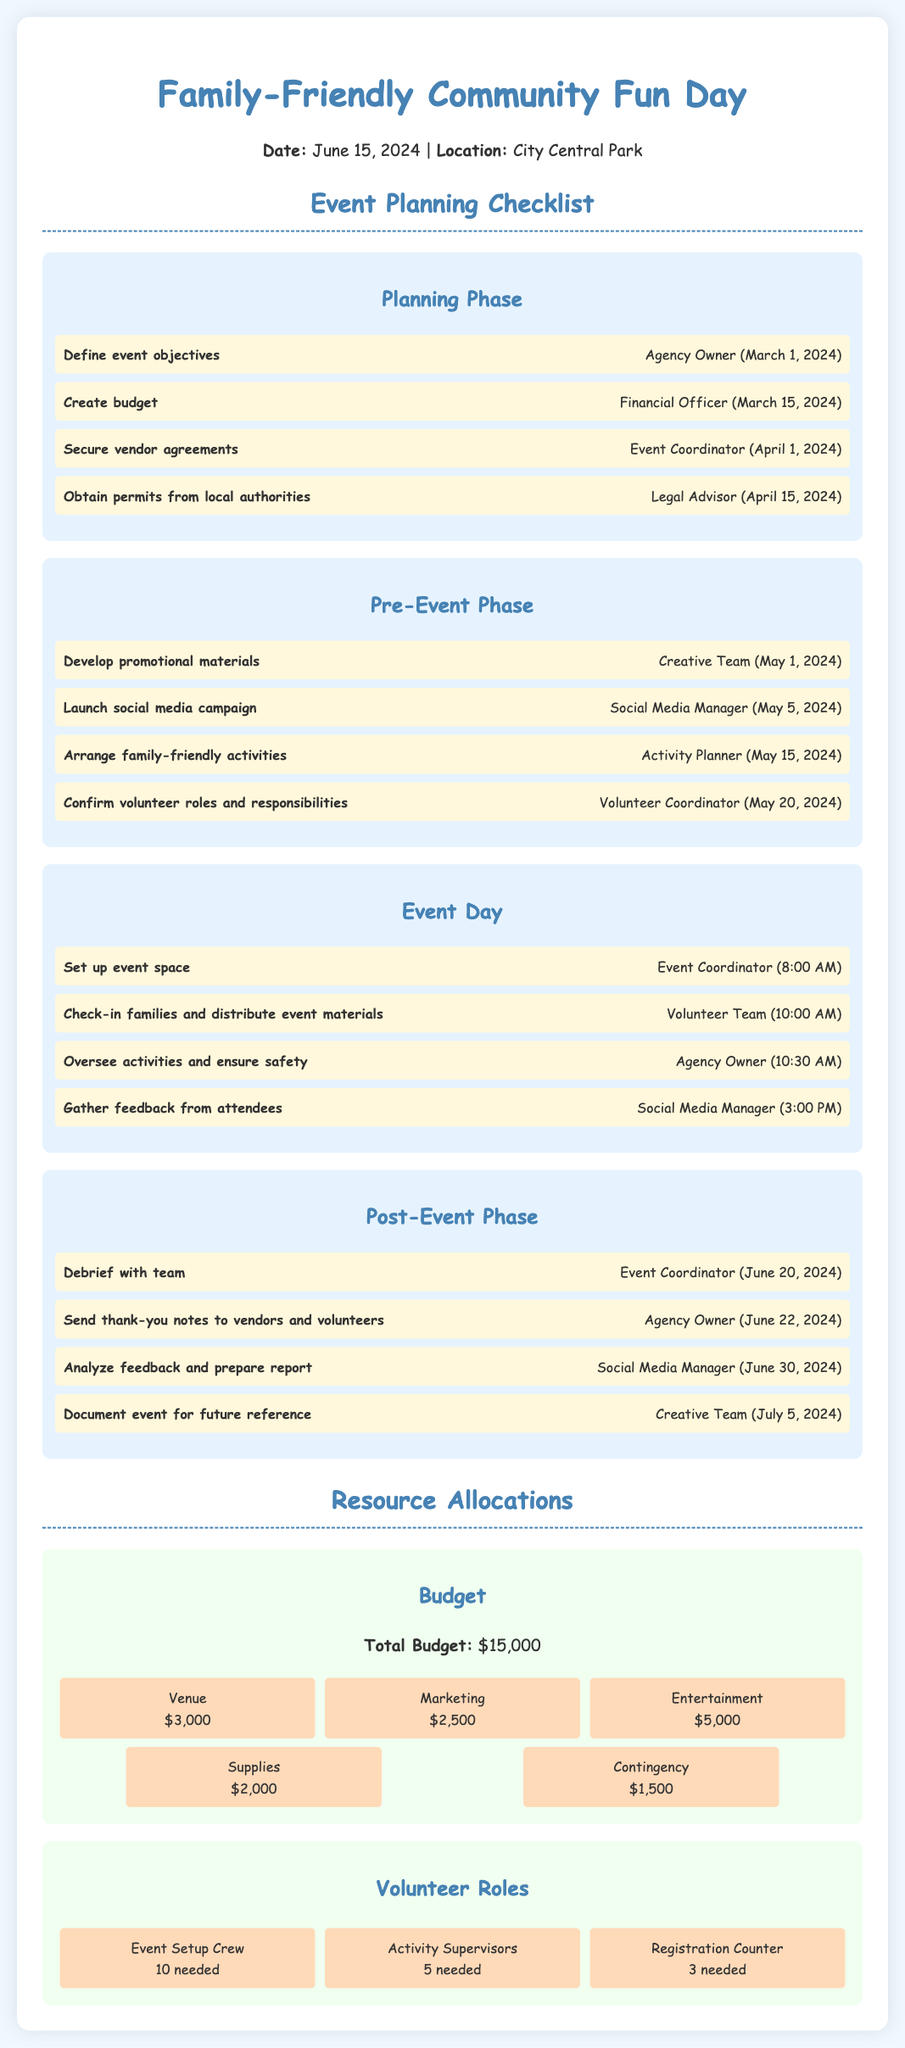What is the date of the event? The date of the event is mentioned at the top of the document.
Answer: June 15, 2024 Who is responsible for securing vendor agreements? The document lists responsibilities next to each task, showing who is accountable.
Answer: Event Coordinator What is the budget for entertainment? The budget breakdown section lists specific amounts allocated for various categories, including entertainment.
Answer: $5,000 When is the feedback gathering scheduled? The timeline specifies when attendees' feedback will be collected during the event day.
Answer: 3:00 PM How many volunteers are needed for the Registration Counter? The volunteer roles section indicates the number of people required for each role.
Answer: 3 needed What is the total budget for the event? The total budget is stated clearly in the budget section.
Answer: $15,000 What is the purpose of the debrief meeting? The debrief is listed as a post-event phase task, emphasizing its importance in evaluating the event's success.
Answer: Analyze the event When does the Creative Team need to document the event? A specific date is assigned to this task in the post-event phase of the document.
Answer: July 5, 2024 Which team is responsible for developing promotional materials? The pre-event phase lists tasks along with the responsible teams.
Answer: Creative Team 